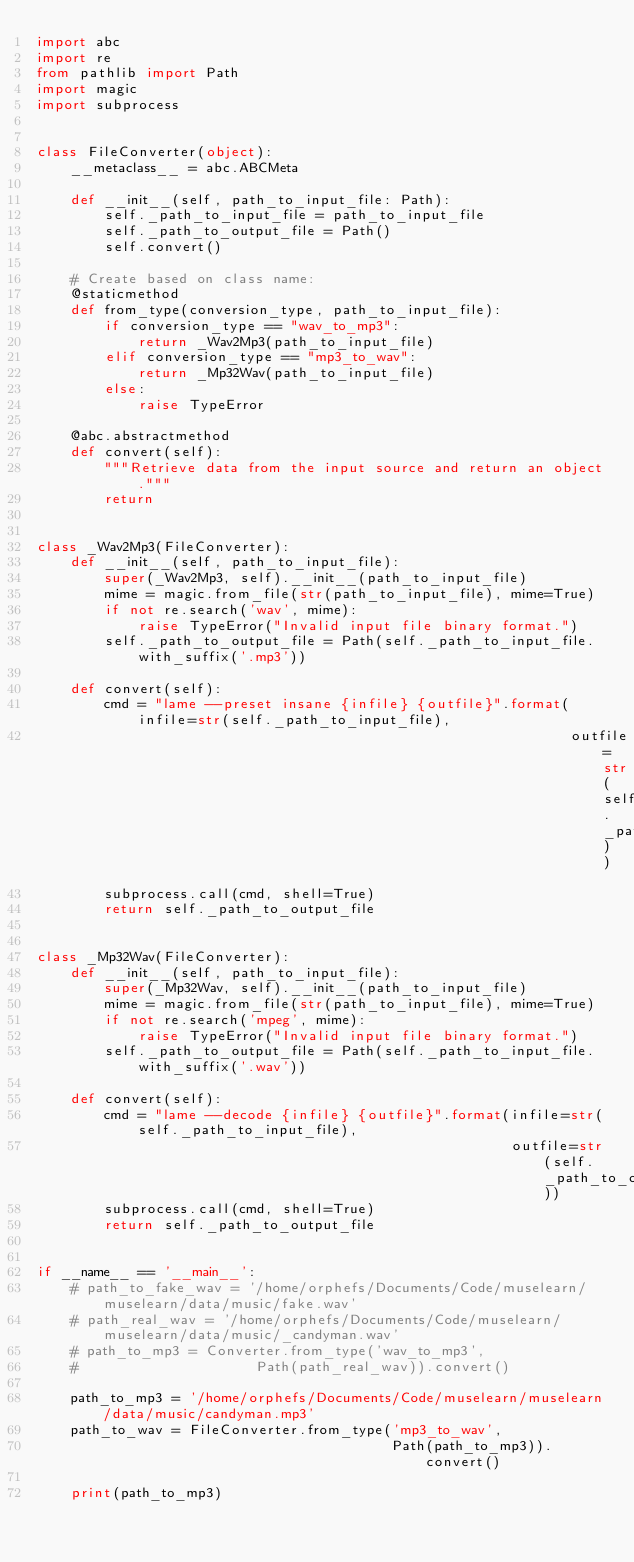<code> <loc_0><loc_0><loc_500><loc_500><_Python_>import abc
import re
from pathlib import Path
import magic
import subprocess


class FileConverter(object):
    __metaclass__ = abc.ABCMeta

    def __init__(self, path_to_input_file: Path):
        self._path_to_input_file = path_to_input_file
        self._path_to_output_file = Path()
        self.convert()

    # Create based on class name:
    @staticmethod
    def from_type(conversion_type, path_to_input_file):
        if conversion_type == "wav_to_mp3":
            return _Wav2Mp3(path_to_input_file)
        elif conversion_type == "mp3_to_wav":
            return _Mp32Wav(path_to_input_file)
        else:
            raise TypeError

    @abc.abstractmethod
    def convert(self):
        """Retrieve data from the input source and return an object."""
        return


class _Wav2Mp3(FileConverter):
    def __init__(self, path_to_input_file):
        super(_Wav2Mp3, self).__init__(path_to_input_file)
        mime = magic.from_file(str(path_to_input_file), mime=True)
        if not re.search('wav', mime):
            raise TypeError("Invalid input file binary format.")
        self._path_to_output_file = Path(self._path_to_input_file.with_suffix('.mp3'))

    def convert(self):
        cmd = "lame --preset insane {infile} {outfile}".format(infile=str(self._path_to_input_file),
                                                               outfile=str(self._path_to_output_file))
        subprocess.call(cmd, shell=True)
        return self._path_to_output_file


class _Mp32Wav(FileConverter):
    def __init__(self, path_to_input_file):
        super(_Mp32Wav, self).__init__(path_to_input_file)
        mime = magic.from_file(str(path_to_input_file), mime=True)
        if not re.search('mpeg', mime):
            raise TypeError("Invalid input file binary format.")
        self._path_to_output_file = Path(self._path_to_input_file.with_suffix('.wav'))

    def convert(self):
        cmd = "lame --decode {infile} {outfile}".format(infile=str(self._path_to_input_file),
                                                        outfile=str(self._path_to_output_file))
        subprocess.call(cmd, shell=True)
        return self._path_to_output_file


if __name__ == '__main__':
    # path_to_fake_wav = '/home/orphefs/Documents/Code/muselearn/muselearn/data/music/fake.wav'
    # path_real_wav = '/home/orphefs/Documents/Code/muselearn/muselearn/data/music/_candyman.wav'
    # path_to_mp3 = Converter.from_type('wav_to_mp3',
    #                     Path(path_real_wav)).convert()

    path_to_mp3 = '/home/orphefs/Documents/Code/muselearn/muselearn/data/music/candyman.mp3'
    path_to_wav = FileConverter.from_type('mp3_to_wav',
                                          Path(path_to_mp3)).convert()

    print(path_to_mp3)
</code> 